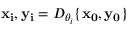<formula> <loc_0><loc_0><loc_500><loc_500>x _ { i } , y _ { i } = D _ { \theta _ { i } } \{ x _ { 0 } , y _ { 0 } \}</formula> 